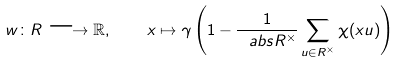Convert formula to latex. <formula><loc_0><loc_0><loc_500><loc_500>w \colon R \longrightarrow { \mathbb { R } } , \quad x \mapsto \gamma \left ( 1 - \frac { 1 } { \ a b s { R ^ { \times } } } \sum _ { u \in R ^ { \times } } \chi ( x u ) \right )</formula> 